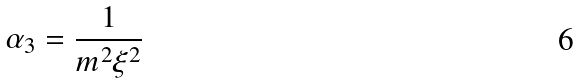Convert formula to latex. <formula><loc_0><loc_0><loc_500><loc_500>\alpha _ { 3 } = \frac { 1 } { m ^ { 2 } \xi ^ { 2 } }</formula> 